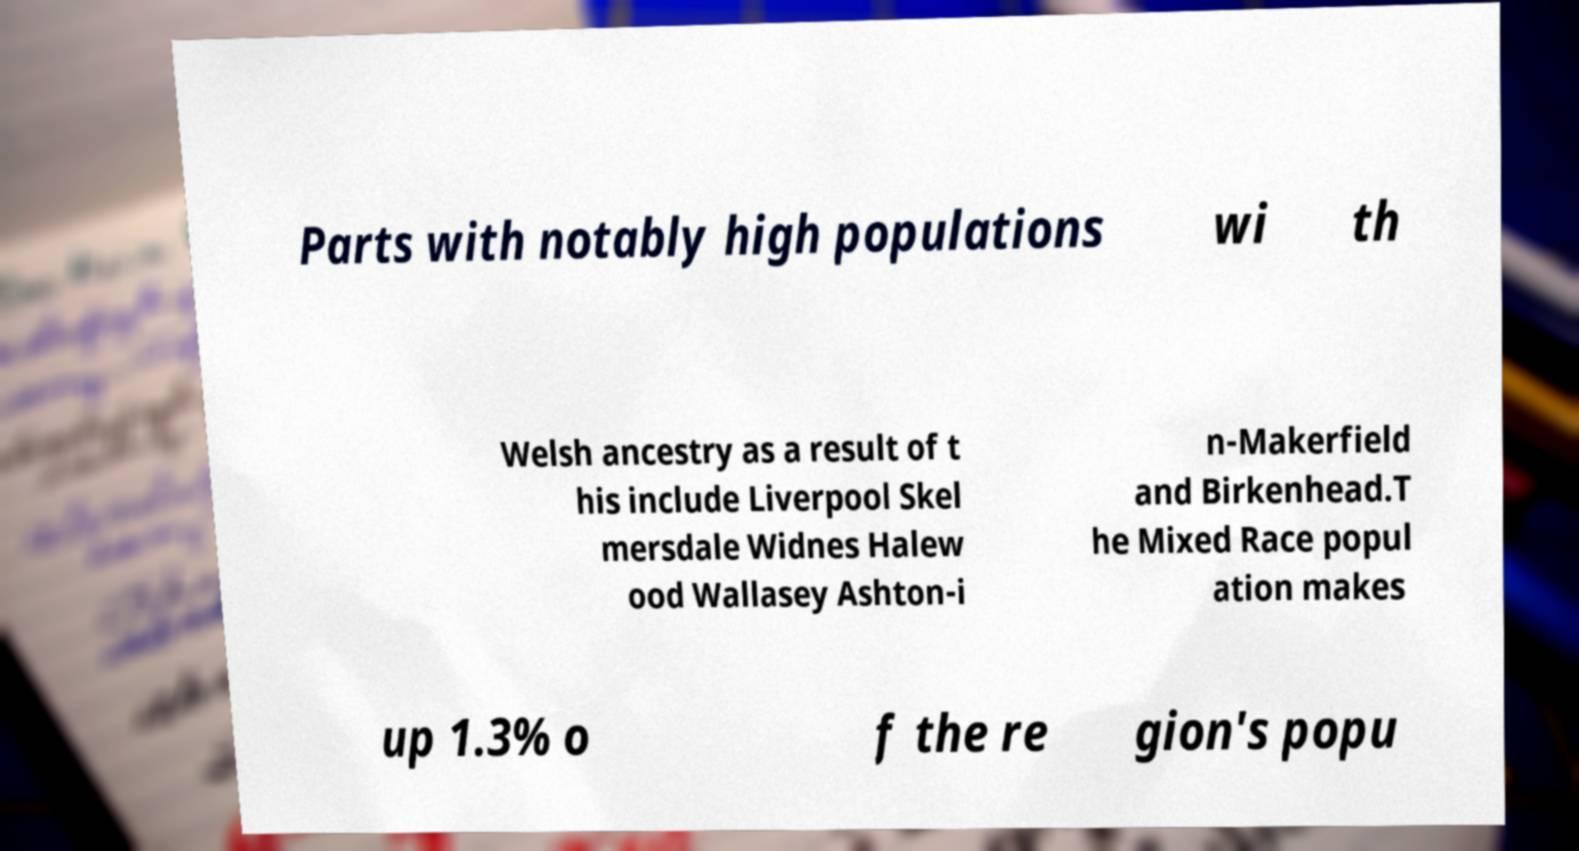There's text embedded in this image that I need extracted. Can you transcribe it verbatim? Parts with notably high populations wi th Welsh ancestry as a result of t his include Liverpool Skel mersdale Widnes Halew ood Wallasey Ashton-i n-Makerfield and Birkenhead.T he Mixed Race popul ation makes up 1.3% o f the re gion's popu 